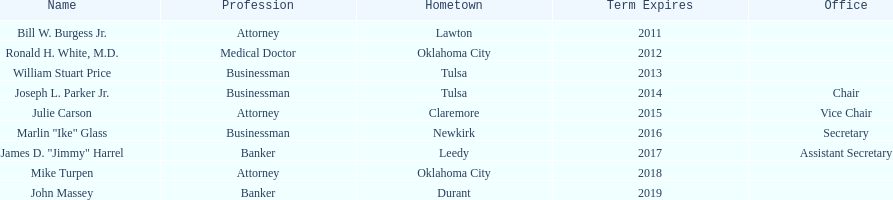What is the total amount of current state regents who are bankers? 2. 